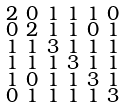Convert formula to latex. <formula><loc_0><loc_0><loc_500><loc_500>\begin{smallmatrix} 2 & 0 & 1 & 1 & 1 & 0 \\ 0 & 2 & 1 & 1 & 0 & 1 \\ 1 & 1 & 3 & 1 & 1 & 1 \\ 1 & 1 & 1 & 3 & 1 & 1 \\ 1 & 0 & 1 & 1 & 3 & 1 \\ 0 & 1 & 1 & 1 & 1 & 3 \end{smallmatrix}</formula> 